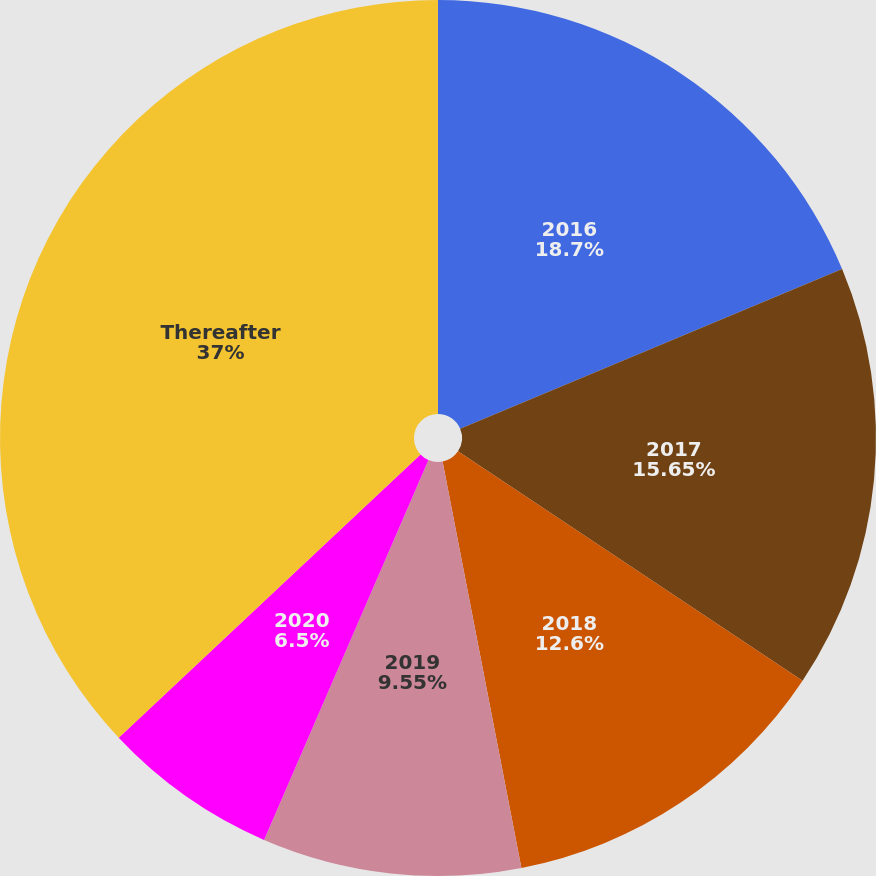<chart> <loc_0><loc_0><loc_500><loc_500><pie_chart><fcel>2016<fcel>2017<fcel>2018<fcel>2019<fcel>2020<fcel>Thereafter<nl><fcel>18.7%<fcel>15.65%<fcel>12.6%<fcel>9.55%<fcel>6.5%<fcel>37.0%<nl></chart> 